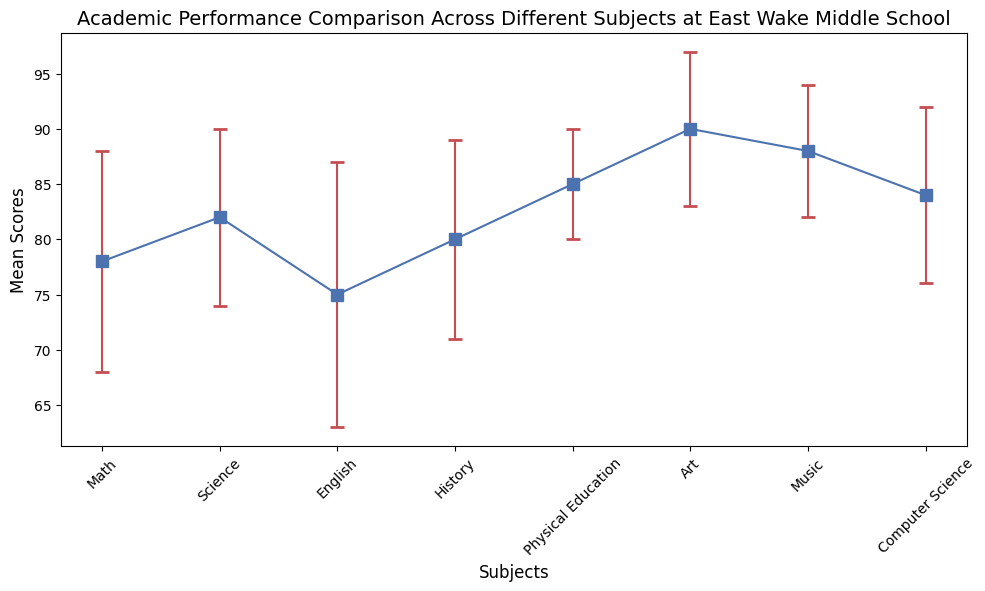Which subject has the highest mean score? First, look at the mean scores of all the subjects. Art has the highest mean score of 90 among all the subjects.
Answer: Art Which subject has the lowest mean score? The subject with the lowest mean score is found by comparing all the mean scores. English has the lowest mean score of 75.
Answer: English What is the mean score difference between Science and Math? Look at the mean scores for Science (82) and Math (78), then subtract Math's score from Science's score. The difference is 82 - 78 = 4.
Answer: 4 Which subject has the largest error bar? Look at the length of the error bars on the chart. English has the largest error bar, represented by its standard deviation of 12.
Answer: English Is the mean score for Computer Science greater than the mean score for History? Compare the mean scores: Computer Science has a mean score of 84, while History has a mean score of 80. 84 > 80, so Computer Science's mean score is greater.
Answer: Yes What is the sum of the mean scores of Art and Music? Look at the mean scores of Art (90) and Music (88), and then sum them: 90 + 88 = 178.
Answer: 178 Which two subjects have the closest mean scores? Compare the mean scores of all subjects to find the ones closest in value. Math (78) and English (75) are closest with a difference of 3.
Answer: Math and English What is the average mean score across all subjects? Sum all the mean scores (78 + 82 + 75 + 80 + 85 + 90 + 88 + 84 = 662) and divide by the number of subjects (8). The average is 662 / 8 = 82.75.
Answer: 82.75 By how much does the standard deviation of Physical Education differ from that of Science? Compare the standard deviations: Physical Education (5) and Science (8), and find the difference: 8 - 5 = 3.
Answer: 3 What is the ratio of the mean score of Art to that of Math? Compare the mean score of Art (90) with that of Math (78) and find the ratio: 90 : 78, which simplifies to 15 : 13.
Answer: 15:13 